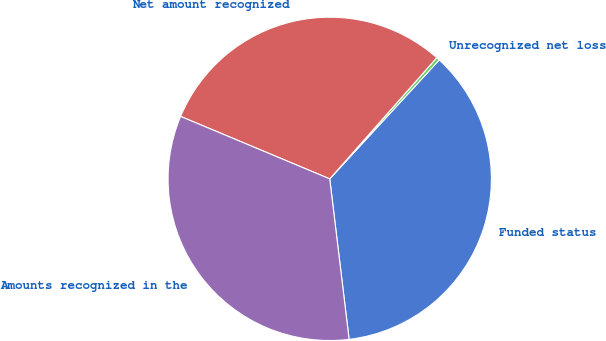Convert chart to OTSL. <chart><loc_0><loc_0><loc_500><loc_500><pie_chart><fcel>Funded status<fcel>Unrecognized net loss<fcel>Net amount recognized<fcel>Amounts recognized in the<nl><fcel>36.24%<fcel>0.33%<fcel>30.2%<fcel>33.22%<nl></chart> 